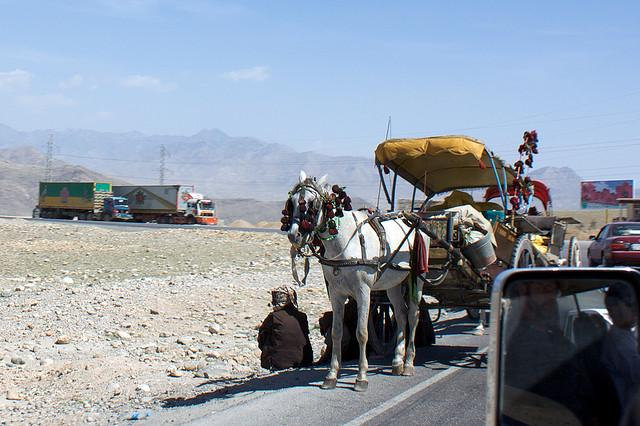In which continent is this road located? asia 